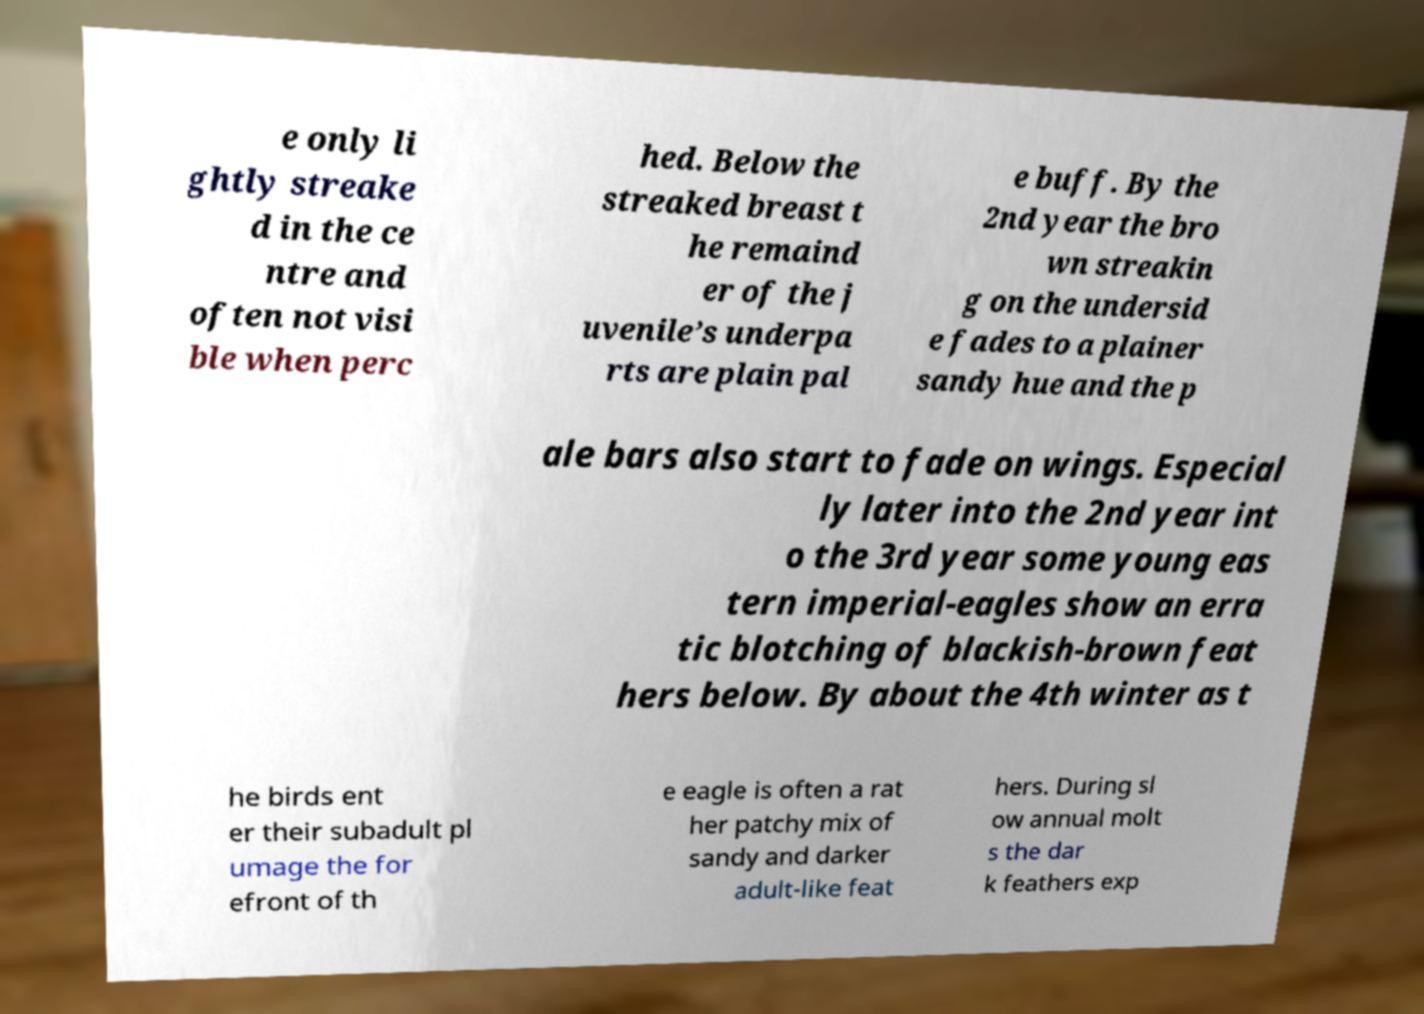I need the written content from this picture converted into text. Can you do that? e only li ghtly streake d in the ce ntre and often not visi ble when perc hed. Below the streaked breast t he remaind er of the j uvenile’s underpa rts are plain pal e buff. By the 2nd year the bro wn streakin g on the undersid e fades to a plainer sandy hue and the p ale bars also start to fade on wings. Especial ly later into the 2nd year int o the 3rd year some young eas tern imperial-eagles show an erra tic blotching of blackish-brown feat hers below. By about the 4th winter as t he birds ent er their subadult pl umage the for efront of th e eagle is often a rat her patchy mix of sandy and darker adult-like feat hers. During sl ow annual molt s the dar k feathers exp 